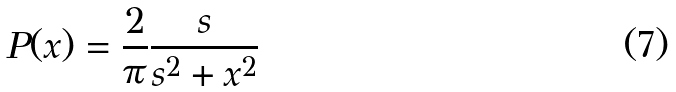Convert formula to latex. <formula><loc_0><loc_0><loc_500><loc_500>P ( x ) = \frac { 2 } { \pi } \frac { s } { s ^ { 2 } + x ^ { 2 } }</formula> 